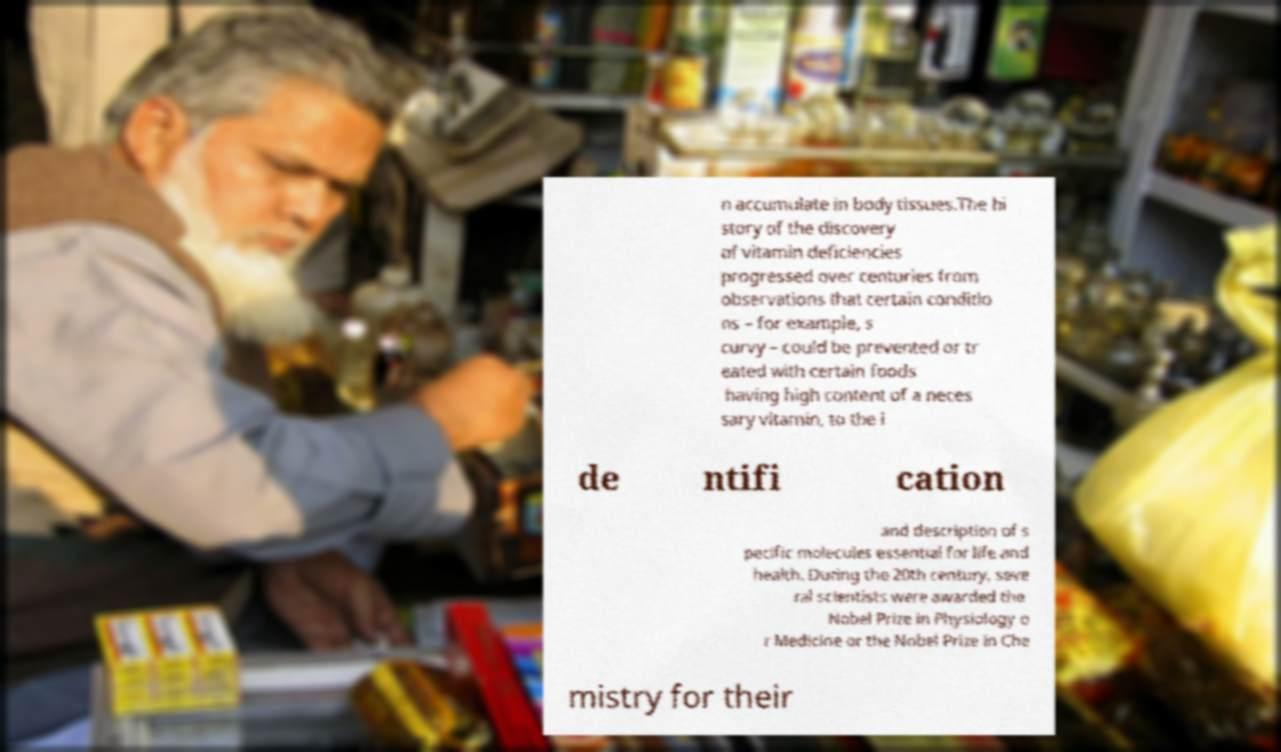There's text embedded in this image that I need extracted. Can you transcribe it verbatim? n accumulate in body tissues.The hi story of the discovery of vitamin deficiencies progressed over centuries from observations that certain conditio ns – for example, s curvy – could be prevented or tr eated with certain foods having high content of a neces sary vitamin, to the i de ntifi cation and description of s pecific molecules essential for life and health. During the 20th century, seve ral scientists were awarded the Nobel Prize in Physiology o r Medicine or the Nobel Prize in Che mistry for their 